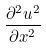<formula> <loc_0><loc_0><loc_500><loc_500>\frac { \partial ^ { 2 } u ^ { 2 } } { \partial x ^ { 2 } }</formula> 